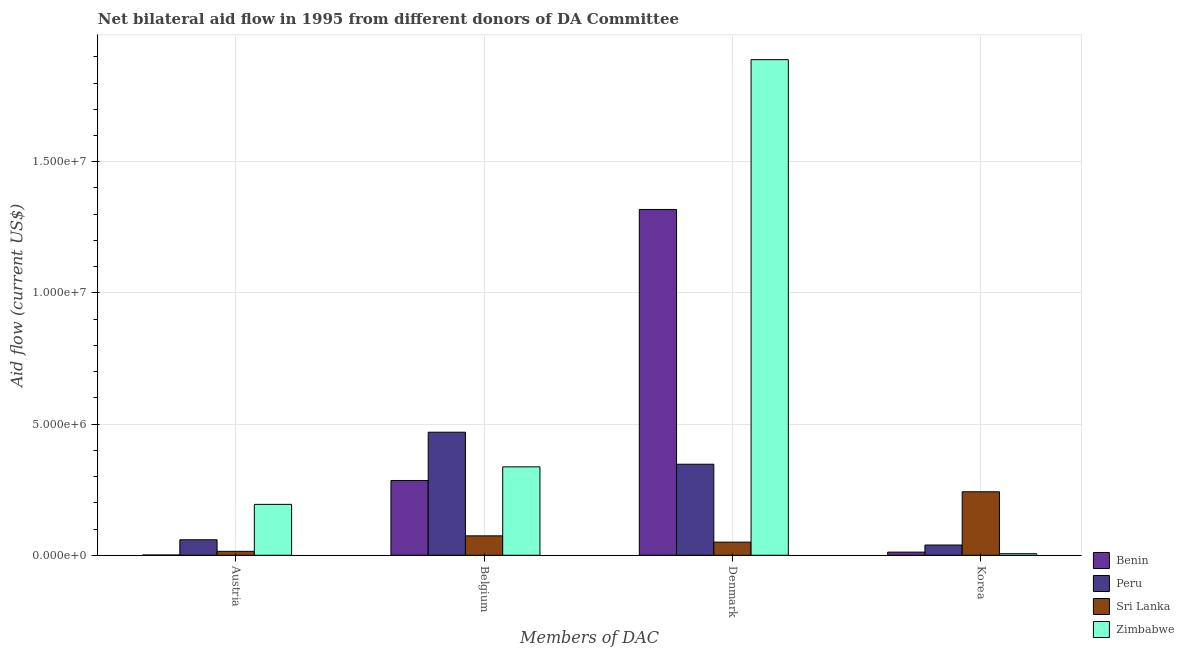How many different coloured bars are there?
Provide a succinct answer. 4. Are the number of bars on each tick of the X-axis equal?
Ensure brevity in your answer.  Yes. How many bars are there on the 3rd tick from the right?
Offer a very short reply. 4. What is the label of the 2nd group of bars from the left?
Ensure brevity in your answer.  Belgium. What is the amount of aid given by korea in Benin?
Make the answer very short. 1.20e+05. Across all countries, what is the maximum amount of aid given by austria?
Provide a short and direct response. 1.94e+06. Across all countries, what is the minimum amount of aid given by korea?
Provide a succinct answer. 6.00e+04. In which country was the amount of aid given by belgium maximum?
Ensure brevity in your answer.  Peru. In which country was the amount of aid given by austria minimum?
Keep it short and to the point. Benin. What is the total amount of aid given by denmark in the graph?
Ensure brevity in your answer.  3.60e+07. What is the difference between the amount of aid given by belgium in Sri Lanka and that in Peru?
Offer a very short reply. -3.95e+06. What is the difference between the amount of aid given by korea in Zimbabwe and the amount of aid given by belgium in Peru?
Ensure brevity in your answer.  -4.63e+06. What is the average amount of aid given by belgium per country?
Offer a terse response. 2.91e+06. What is the difference between the amount of aid given by austria and amount of aid given by belgium in Benin?
Make the answer very short. -2.84e+06. In how many countries, is the amount of aid given by korea greater than 9000000 US$?
Provide a short and direct response. 0. What is the difference between the highest and the second highest amount of aid given by austria?
Your answer should be compact. 1.35e+06. What is the difference between the highest and the lowest amount of aid given by austria?
Provide a succinct answer. 1.93e+06. In how many countries, is the amount of aid given by belgium greater than the average amount of aid given by belgium taken over all countries?
Provide a succinct answer. 2. What does the 3rd bar from the left in Denmark represents?
Your answer should be compact. Sri Lanka. What does the 1st bar from the right in Belgium represents?
Your answer should be very brief. Zimbabwe. Is it the case that in every country, the sum of the amount of aid given by austria and amount of aid given by belgium is greater than the amount of aid given by denmark?
Offer a terse response. No. How many bars are there?
Make the answer very short. 16. Are all the bars in the graph horizontal?
Keep it short and to the point. No. How many countries are there in the graph?
Make the answer very short. 4. What is the difference between two consecutive major ticks on the Y-axis?
Ensure brevity in your answer.  5.00e+06. Are the values on the major ticks of Y-axis written in scientific E-notation?
Offer a very short reply. Yes. Does the graph contain grids?
Your answer should be compact. Yes. Where does the legend appear in the graph?
Make the answer very short. Bottom right. What is the title of the graph?
Make the answer very short. Net bilateral aid flow in 1995 from different donors of DA Committee. Does "Georgia" appear as one of the legend labels in the graph?
Provide a succinct answer. No. What is the label or title of the X-axis?
Your answer should be very brief. Members of DAC. What is the Aid flow (current US$) of Peru in Austria?
Offer a terse response. 5.90e+05. What is the Aid flow (current US$) in Sri Lanka in Austria?
Ensure brevity in your answer.  1.50e+05. What is the Aid flow (current US$) in Zimbabwe in Austria?
Make the answer very short. 1.94e+06. What is the Aid flow (current US$) in Benin in Belgium?
Keep it short and to the point. 2.85e+06. What is the Aid flow (current US$) of Peru in Belgium?
Make the answer very short. 4.69e+06. What is the Aid flow (current US$) of Sri Lanka in Belgium?
Your response must be concise. 7.40e+05. What is the Aid flow (current US$) of Zimbabwe in Belgium?
Offer a very short reply. 3.37e+06. What is the Aid flow (current US$) of Benin in Denmark?
Ensure brevity in your answer.  1.32e+07. What is the Aid flow (current US$) in Peru in Denmark?
Your answer should be compact. 3.47e+06. What is the Aid flow (current US$) of Sri Lanka in Denmark?
Offer a very short reply. 5.00e+05. What is the Aid flow (current US$) in Zimbabwe in Denmark?
Make the answer very short. 1.89e+07. What is the Aid flow (current US$) of Sri Lanka in Korea?
Your response must be concise. 2.42e+06. Across all Members of DAC, what is the maximum Aid flow (current US$) in Benin?
Your response must be concise. 1.32e+07. Across all Members of DAC, what is the maximum Aid flow (current US$) of Peru?
Give a very brief answer. 4.69e+06. Across all Members of DAC, what is the maximum Aid flow (current US$) in Sri Lanka?
Offer a very short reply. 2.42e+06. Across all Members of DAC, what is the maximum Aid flow (current US$) in Zimbabwe?
Offer a terse response. 1.89e+07. Across all Members of DAC, what is the minimum Aid flow (current US$) of Sri Lanka?
Offer a terse response. 1.50e+05. Across all Members of DAC, what is the minimum Aid flow (current US$) of Zimbabwe?
Give a very brief answer. 6.00e+04. What is the total Aid flow (current US$) in Benin in the graph?
Provide a succinct answer. 1.62e+07. What is the total Aid flow (current US$) of Peru in the graph?
Provide a succinct answer. 9.14e+06. What is the total Aid flow (current US$) of Sri Lanka in the graph?
Give a very brief answer. 3.81e+06. What is the total Aid flow (current US$) in Zimbabwe in the graph?
Provide a succinct answer. 2.43e+07. What is the difference between the Aid flow (current US$) in Benin in Austria and that in Belgium?
Your answer should be compact. -2.84e+06. What is the difference between the Aid flow (current US$) of Peru in Austria and that in Belgium?
Provide a succinct answer. -4.10e+06. What is the difference between the Aid flow (current US$) of Sri Lanka in Austria and that in Belgium?
Your answer should be very brief. -5.90e+05. What is the difference between the Aid flow (current US$) of Zimbabwe in Austria and that in Belgium?
Your answer should be very brief. -1.43e+06. What is the difference between the Aid flow (current US$) of Benin in Austria and that in Denmark?
Provide a succinct answer. -1.32e+07. What is the difference between the Aid flow (current US$) in Peru in Austria and that in Denmark?
Keep it short and to the point. -2.88e+06. What is the difference between the Aid flow (current US$) of Sri Lanka in Austria and that in Denmark?
Ensure brevity in your answer.  -3.50e+05. What is the difference between the Aid flow (current US$) of Zimbabwe in Austria and that in Denmark?
Offer a terse response. -1.70e+07. What is the difference between the Aid flow (current US$) in Benin in Austria and that in Korea?
Offer a very short reply. -1.10e+05. What is the difference between the Aid flow (current US$) in Peru in Austria and that in Korea?
Offer a very short reply. 2.00e+05. What is the difference between the Aid flow (current US$) of Sri Lanka in Austria and that in Korea?
Provide a short and direct response. -2.27e+06. What is the difference between the Aid flow (current US$) of Zimbabwe in Austria and that in Korea?
Your answer should be compact. 1.88e+06. What is the difference between the Aid flow (current US$) of Benin in Belgium and that in Denmark?
Make the answer very short. -1.03e+07. What is the difference between the Aid flow (current US$) of Peru in Belgium and that in Denmark?
Offer a very short reply. 1.22e+06. What is the difference between the Aid flow (current US$) in Sri Lanka in Belgium and that in Denmark?
Ensure brevity in your answer.  2.40e+05. What is the difference between the Aid flow (current US$) of Zimbabwe in Belgium and that in Denmark?
Provide a short and direct response. -1.55e+07. What is the difference between the Aid flow (current US$) in Benin in Belgium and that in Korea?
Give a very brief answer. 2.73e+06. What is the difference between the Aid flow (current US$) of Peru in Belgium and that in Korea?
Keep it short and to the point. 4.30e+06. What is the difference between the Aid flow (current US$) in Sri Lanka in Belgium and that in Korea?
Offer a very short reply. -1.68e+06. What is the difference between the Aid flow (current US$) in Zimbabwe in Belgium and that in Korea?
Your answer should be compact. 3.31e+06. What is the difference between the Aid flow (current US$) in Benin in Denmark and that in Korea?
Your answer should be compact. 1.31e+07. What is the difference between the Aid flow (current US$) of Peru in Denmark and that in Korea?
Provide a short and direct response. 3.08e+06. What is the difference between the Aid flow (current US$) in Sri Lanka in Denmark and that in Korea?
Provide a short and direct response. -1.92e+06. What is the difference between the Aid flow (current US$) in Zimbabwe in Denmark and that in Korea?
Offer a terse response. 1.88e+07. What is the difference between the Aid flow (current US$) in Benin in Austria and the Aid flow (current US$) in Peru in Belgium?
Give a very brief answer. -4.68e+06. What is the difference between the Aid flow (current US$) in Benin in Austria and the Aid flow (current US$) in Sri Lanka in Belgium?
Give a very brief answer. -7.30e+05. What is the difference between the Aid flow (current US$) of Benin in Austria and the Aid flow (current US$) of Zimbabwe in Belgium?
Your answer should be compact. -3.36e+06. What is the difference between the Aid flow (current US$) of Peru in Austria and the Aid flow (current US$) of Sri Lanka in Belgium?
Give a very brief answer. -1.50e+05. What is the difference between the Aid flow (current US$) in Peru in Austria and the Aid flow (current US$) in Zimbabwe in Belgium?
Your answer should be very brief. -2.78e+06. What is the difference between the Aid flow (current US$) of Sri Lanka in Austria and the Aid flow (current US$) of Zimbabwe in Belgium?
Offer a terse response. -3.22e+06. What is the difference between the Aid flow (current US$) of Benin in Austria and the Aid flow (current US$) of Peru in Denmark?
Your answer should be very brief. -3.46e+06. What is the difference between the Aid flow (current US$) of Benin in Austria and the Aid flow (current US$) of Sri Lanka in Denmark?
Provide a short and direct response. -4.90e+05. What is the difference between the Aid flow (current US$) of Benin in Austria and the Aid flow (current US$) of Zimbabwe in Denmark?
Provide a short and direct response. -1.89e+07. What is the difference between the Aid flow (current US$) in Peru in Austria and the Aid flow (current US$) in Zimbabwe in Denmark?
Provide a succinct answer. -1.83e+07. What is the difference between the Aid flow (current US$) in Sri Lanka in Austria and the Aid flow (current US$) in Zimbabwe in Denmark?
Make the answer very short. -1.87e+07. What is the difference between the Aid flow (current US$) of Benin in Austria and the Aid flow (current US$) of Peru in Korea?
Your answer should be compact. -3.80e+05. What is the difference between the Aid flow (current US$) of Benin in Austria and the Aid flow (current US$) of Sri Lanka in Korea?
Ensure brevity in your answer.  -2.41e+06. What is the difference between the Aid flow (current US$) of Peru in Austria and the Aid flow (current US$) of Sri Lanka in Korea?
Make the answer very short. -1.83e+06. What is the difference between the Aid flow (current US$) in Peru in Austria and the Aid flow (current US$) in Zimbabwe in Korea?
Keep it short and to the point. 5.30e+05. What is the difference between the Aid flow (current US$) of Sri Lanka in Austria and the Aid flow (current US$) of Zimbabwe in Korea?
Your answer should be very brief. 9.00e+04. What is the difference between the Aid flow (current US$) in Benin in Belgium and the Aid flow (current US$) in Peru in Denmark?
Your answer should be very brief. -6.20e+05. What is the difference between the Aid flow (current US$) of Benin in Belgium and the Aid flow (current US$) of Sri Lanka in Denmark?
Give a very brief answer. 2.35e+06. What is the difference between the Aid flow (current US$) in Benin in Belgium and the Aid flow (current US$) in Zimbabwe in Denmark?
Your answer should be very brief. -1.60e+07. What is the difference between the Aid flow (current US$) in Peru in Belgium and the Aid flow (current US$) in Sri Lanka in Denmark?
Your response must be concise. 4.19e+06. What is the difference between the Aid flow (current US$) in Peru in Belgium and the Aid flow (current US$) in Zimbabwe in Denmark?
Your answer should be very brief. -1.42e+07. What is the difference between the Aid flow (current US$) of Sri Lanka in Belgium and the Aid flow (current US$) of Zimbabwe in Denmark?
Keep it short and to the point. -1.82e+07. What is the difference between the Aid flow (current US$) in Benin in Belgium and the Aid flow (current US$) in Peru in Korea?
Offer a terse response. 2.46e+06. What is the difference between the Aid flow (current US$) in Benin in Belgium and the Aid flow (current US$) in Sri Lanka in Korea?
Your answer should be compact. 4.30e+05. What is the difference between the Aid flow (current US$) in Benin in Belgium and the Aid flow (current US$) in Zimbabwe in Korea?
Give a very brief answer. 2.79e+06. What is the difference between the Aid flow (current US$) in Peru in Belgium and the Aid flow (current US$) in Sri Lanka in Korea?
Keep it short and to the point. 2.27e+06. What is the difference between the Aid flow (current US$) of Peru in Belgium and the Aid flow (current US$) of Zimbabwe in Korea?
Offer a terse response. 4.63e+06. What is the difference between the Aid flow (current US$) in Sri Lanka in Belgium and the Aid flow (current US$) in Zimbabwe in Korea?
Keep it short and to the point. 6.80e+05. What is the difference between the Aid flow (current US$) in Benin in Denmark and the Aid flow (current US$) in Peru in Korea?
Make the answer very short. 1.28e+07. What is the difference between the Aid flow (current US$) of Benin in Denmark and the Aid flow (current US$) of Sri Lanka in Korea?
Provide a short and direct response. 1.08e+07. What is the difference between the Aid flow (current US$) of Benin in Denmark and the Aid flow (current US$) of Zimbabwe in Korea?
Keep it short and to the point. 1.31e+07. What is the difference between the Aid flow (current US$) in Peru in Denmark and the Aid flow (current US$) in Sri Lanka in Korea?
Your answer should be very brief. 1.05e+06. What is the difference between the Aid flow (current US$) of Peru in Denmark and the Aid flow (current US$) of Zimbabwe in Korea?
Offer a terse response. 3.41e+06. What is the average Aid flow (current US$) in Benin per Members of DAC?
Offer a terse response. 4.04e+06. What is the average Aid flow (current US$) in Peru per Members of DAC?
Ensure brevity in your answer.  2.28e+06. What is the average Aid flow (current US$) of Sri Lanka per Members of DAC?
Offer a terse response. 9.52e+05. What is the average Aid flow (current US$) of Zimbabwe per Members of DAC?
Offer a terse response. 6.06e+06. What is the difference between the Aid flow (current US$) of Benin and Aid flow (current US$) of Peru in Austria?
Your answer should be very brief. -5.80e+05. What is the difference between the Aid flow (current US$) in Benin and Aid flow (current US$) in Sri Lanka in Austria?
Make the answer very short. -1.40e+05. What is the difference between the Aid flow (current US$) in Benin and Aid flow (current US$) in Zimbabwe in Austria?
Give a very brief answer. -1.93e+06. What is the difference between the Aid flow (current US$) of Peru and Aid flow (current US$) of Sri Lanka in Austria?
Offer a very short reply. 4.40e+05. What is the difference between the Aid flow (current US$) of Peru and Aid flow (current US$) of Zimbabwe in Austria?
Offer a terse response. -1.35e+06. What is the difference between the Aid flow (current US$) of Sri Lanka and Aid flow (current US$) of Zimbabwe in Austria?
Ensure brevity in your answer.  -1.79e+06. What is the difference between the Aid flow (current US$) in Benin and Aid flow (current US$) in Peru in Belgium?
Keep it short and to the point. -1.84e+06. What is the difference between the Aid flow (current US$) in Benin and Aid flow (current US$) in Sri Lanka in Belgium?
Provide a short and direct response. 2.11e+06. What is the difference between the Aid flow (current US$) in Benin and Aid flow (current US$) in Zimbabwe in Belgium?
Offer a terse response. -5.20e+05. What is the difference between the Aid flow (current US$) in Peru and Aid flow (current US$) in Sri Lanka in Belgium?
Give a very brief answer. 3.95e+06. What is the difference between the Aid flow (current US$) of Peru and Aid flow (current US$) of Zimbabwe in Belgium?
Give a very brief answer. 1.32e+06. What is the difference between the Aid flow (current US$) in Sri Lanka and Aid flow (current US$) in Zimbabwe in Belgium?
Provide a succinct answer. -2.63e+06. What is the difference between the Aid flow (current US$) in Benin and Aid flow (current US$) in Peru in Denmark?
Offer a terse response. 9.71e+06. What is the difference between the Aid flow (current US$) of Benin and Aid flow (current US$) of Sri Lanka in Denmark?
Your answer should be compact. 1.27e+07. What is the difference between the Aid flow (current US$) in Benin and Aid flow (current US$) in Zimbabwe in Denmark?
Offer a very short reply. -5.71e+06. What is the difference between the Aid flow (current US$) in Peru and Aid flow (current US$) in Sri Lanka in Denmark?
Your answer should be compact. 2.97e+06. What is the difference between the Aid flow (current US$) of Peru and Aid flow (current US$) of Zimbabwe in Denmark?
Your answer should be compact. -1.54e+07. What is the difference between the Aid flow (current US$) in Sri Lanka and Aid flow (current US$) in Zimbabwe in Denmark?
Offer a terse response. -1.84e+07. What is the difference between the Aid flow (current US$) in Benin and Aid flow (current US$) in Sri Lanka in Korea?
Your answer should be very brief. -2.30e+06. What is the difference between the Aid flow (current US$) in Benin and Aid flow (current US$) in Zimbabwe in Korea?
Your response must be concise. 6.00e+04. What is the difference between the Aid flow (current US$) in Peru and Aid flow (current US$) in Sri Lanka in Korea?
Give a very brief answer. -2.03e+06. What is the difference between the Aid flow (current US$) of Peru and Aid flow (current US$) of Zimbabwe in Korea?
Provide a short and direct response. 3.30e+05. What is the difference between the Aid flow (current US$) of Sri Lanka and Aid flow (current US$) of Zimbabwe in Korea?
Your answer should be very brief. 2.36e+06. What is the ratio of the Aid flow (current US$) in Benin in Austria to that in Belgium?
Make the answer very short. 0. What is the ratio of the Aid flow (current US$) in Peru in Austria to that in Belgium?
Your answer should be very brief. 0.13. What is the ratio of the Aid flow (current US$) of Sri Lanka in Austria to that in Belgium?
Your response must be concise. 0.2. What is the ratio of the Aid flow (current US$) of Zimbabwe in Austria to that in Belgium?
Your answer should be compact. 0.58. What is the ratio of the Aid flow (current US$) of Benin in Austria to that in Denmark?
Ensure brevity in your answer.  0. What is the ratio of the Aid flow (current US$) of Peru in Austria to that in Denmark?
Make the answer very short. 0.17. What is the ratio of the Aid flow (current US$) of Sri Lanka in Austria to that in Denmark?
Make the answer very short. 0.3. What is the ratio of the Aid flow (current US$) in Zimbabwe in Austria to that in Denmark?
Ensure brevity in your answer.  0.1. What is the ratio of the Aid flow (current US$) in Benin in Austria to that in Korea?
Make the answer very short. 0.08. What is the ratio of the Aid flow (current US$) of Peru in Austria to that in Korea?
Make the answer very short. 1.51. What is the ratio of the Aid flow (current US$) of Sri Lanka in Austria to that in Korea?
Offer a terse response. 0.06. What is the ratio of the Aid flow (current US$) in Zimbabwe in Austria to that in Korea?
Give a very brief answer. 32.33. What is the ratio of the Aid flow (current US$) of Benin in Belgium to that in Denmark?
Ensure brevity in your answer.  0.22. What is the ratio of the Aid flow (current US$) of Peru in Belgium to that in Denmark?
Ensure brevity in your answer.  1.35. What is the ratio of the Aid flow (current US$) of Sri Lanka in Belgium to that in Denmark?
Ensure brevity in your answer.  1.48. What is the ratio of the Aid flow (current US$) of Zimbabwe in Belgium to that in Denmark?
Give a very brief answer. 0.18. What is the ratio of the Aid flow (current US$) of Benin in Belgium to that in Korea?
Keep it short and to the point. 23.75. What is the ratio of the Aid flow (current US$) of Peru in Belgium to that in Korea?
Ensure brevity in your answer.  12.03. What is the ratio of the Aid flow (current US$) of Sri Lanka in Belgium to that in Korea?
Make the answer very short. 0.31. What is the ratio of the Aid flow (current US$) of Zimbabwe in Belgium to that in Korea?
Offer a terse response. 56.17. What is the ratio of the Aid flow (current US$) of Benin in Denmark to that in Korea?
Your answer should be compact. 109.83. What is the ratio of the Aid flow (current US$) of Peru in Denmark to that in Korea?
Make the answer very short. 8.9. What is the ratio of the Aid flow (current US$) of Sri Lanka in Denmark to that in Korea?
Provide a short and direct response. 0.21. What is the ratio of the Aid flow (current US$) of Zimbabwe in Denmark to that in Korea?
Provide a short and direct response. 314.83. What is the difference between the highest and the second highest Aid flow (current US$) in Benin?
Your answer should be compact. 1.03e+07. What is the difference between the highest and the second highest Aid flow (current US$) in Peru?
Your answer should be compact. 1.22e+06. What is the difference between the highest and the second highest Aid flow (current US$) of Sri Lanka?
Offer a terse response. 1.68e+06. What is the difference between the highest and the second highest Aid flow (current US$) of Zimbabwe?
Your answer should be compact. 1.55e+07. What is the difference between the highest and the lowest Aid flow (current US$) of Benin?
Keep it short and to the point. 1.32e+07. What is the difference between the highest and the lowest Aid flow (current US$) of Peru?
Make the answer very short. 4.30e+06. What is the difference between the highest and the lowest Aid flow (current US$) in Sri Lanka?
Offer a terse response. 2.27e+06. What is the difference between the highest and the lowest Aid flow (current US$) in Zimbabwe?
Provide a succinct answer. 1.88e+07. 